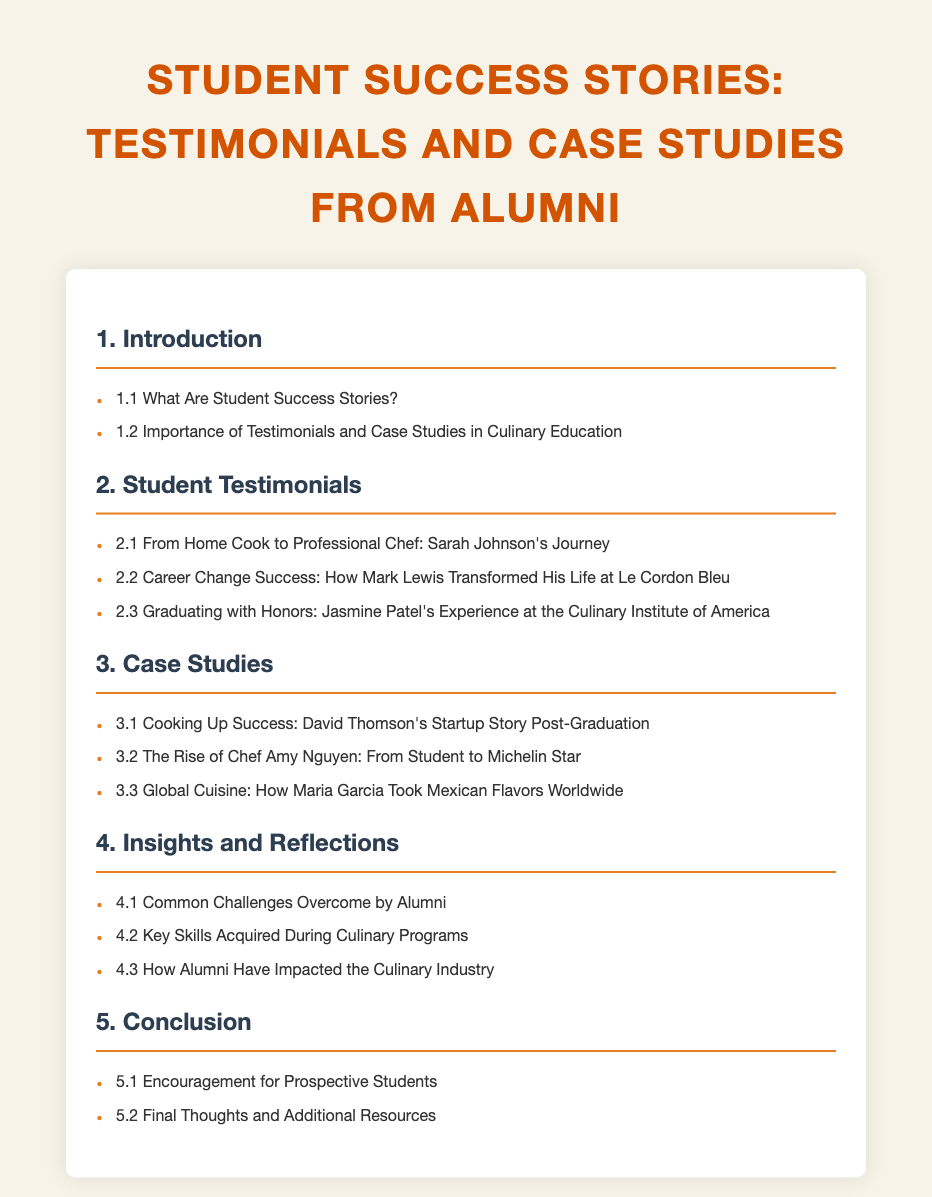What are student success stories? This question looks for the specific definition or explanation found in the document.
Answer: Student success stories are defined in section 1.1 What is the first student testimonial listed? The first testimonial under the Student Testimonials section reveals the name and journey of the individual.
Answer: Sarah Johnson's Journey Who graduated with honors? This question retrieves the name of the alumnus who had an exceptional academic achievement during their program.
Answer: Jasmine Patel What unique achievement did Amy Nguyen accomplish? This requires connecting Amy Nguyen’s journey with her accomplishment within the culinary field mentioned in the document.
Answer: Michelin Star What is the focus of section 4.1? This focuses on common challenges faced by alumni as outlined in the document, hinting at reflections and insights.
Answer: Common Challenges Overcome by Alumni How many case studies are listed? By counting the number of case studies mentioned, this provides concise quantitative information from the document.
Answer: Three What section follows Student Testimonials? This question seeks to understand the structure of the document and the flow between sections.
Answer: Case Studies What is emphasized in section 5.1? This question looks for motivation directed at future students based on the content provided in the conclusion section.
Answer: Encouragement for Prospective Students 